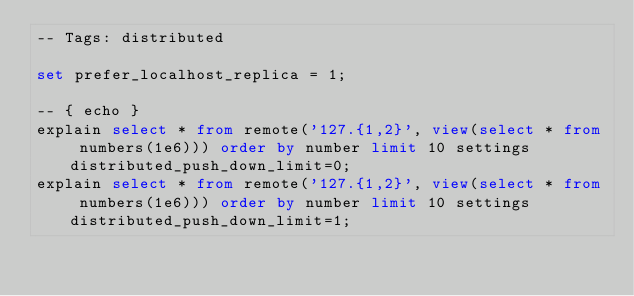Convert code to text. <code><loc_0><loc_0><loc_500><loc_500><_SQL_>-- Tags: distributed

set prefer_localhost_replica = 1;

-- { echo }
explain select * from remote('127.{1,2}', view(select * from numbers(1e6))) order by number limit 10 settings distributed_push_down_limit=0;
explain select * from remote('127.{1,2}', view(select * from numbers(1e6))) order by number limit 10 settings distributed_push_down_limit=1;
</code> 